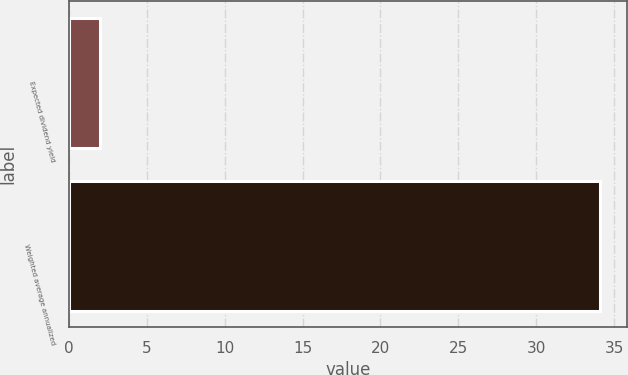<chart> <loc_0><loc_0><loc_500><loc_500><bar_chart><fcel>Expected dividend yield<fcel>Weighted average annualized<nl><fcel>2<fcel>34.1<nl></chart> 